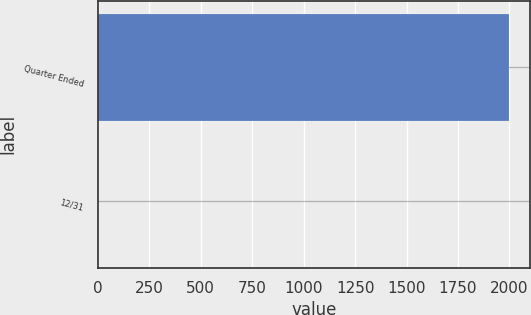Convert chart. <chart><loc_0><loc_0><loc_500><loc_500><bar_chart><fcel>Quarter Ended<fcel>12/31<nl><fcel>2000<fcel>0.61<nl></chart> 